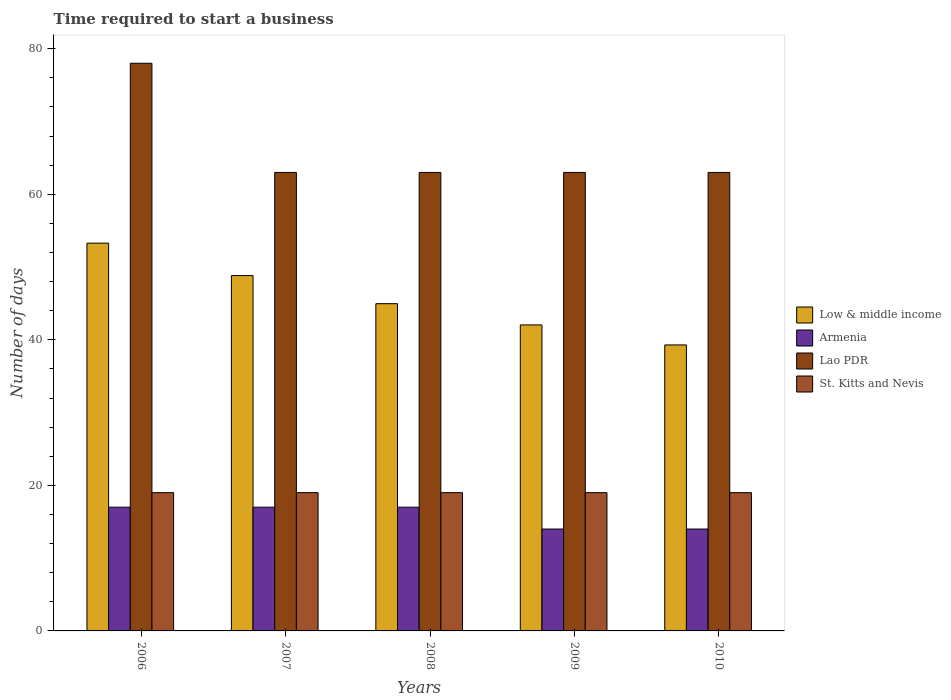How many groups of bars are there?
Keep it short and to the point. 5. Are the number of bars per tick equal to the number of legend labels?
Offer a very short reply. Yes. Are the number of bars on each tick of the X-axis equal?
Your answer should be very brief. Yes. What is the label of the 1st group of bars from the left?
Keep it short and to the point. 2006. In how many cases, is the number of bars for a given year not equal to the number of legend labels?
Offer a very short reply. 0. What is the number of days required to start a business in Low & middle income in 2008?
Provide a short and direct response. 44.97. Across all years, what is the maximum number of days required to start a business in Armenia?
Offer a very short reply. 17. Across all years, what is the minimum number of days required to start a business in Armenia?
Offer a terse response. 14. In which year was the number of days required to start a business in St. Kitts and Nevis maximum?
Your response must be concise. 2006. What is the total number of days required to start a business in Lao PDR in the graph?
Offer a very short reply. 330. What is the difference between the number of days required to start a business in Low & middle income in 2007 and that in 2009?
Provide a succinct answer. 6.78. What is the difference between the number of days required to start a business in Lao PDR in 2007 and the number of days required to start a business in Armenia in 2008?
Your answer should be very brief. 46. In the year 2007, what is the difference between the number of days required to start a business in St. Kitts and Nevis and number of days required to start a business in Armenia?
Your response must be concise. 2. In how many years, is the number of days required to start a business in Lao PDR greater than 12 days?
Provide a short and direct response. 5. Is the number of days required to start a business in Lao PDR in 2006 less than that in 2008?
Offer a terse response. No. What is the difference between the highest and the lowest number of days required to start a business in Low & middle income?
Ensure brevity in your answer.  13.99. In how many years, is the number of days required to start a business in Lao PDR greater than the average number of days required to start a business in Lao PDR taken over all years?
Your response must be concise. 1. What does the 2nd bar from the right in 2007 represents?
Offer a terse response. Lao PDR. Is it the case that in every year, the sum of the number of days required to start a business in St. Kitts and Nevis and number of days required to start a business in Low & middle income is greater than the number of days required to start a business in Lao PDR?
Provide a short and direct response. No. Are the values on the major ticks of Y-axis written in scientific E-notation?
Provide a short and direct response. No. Does the graph contain any zero values?
Your answer should be very brief. No. How many legend labels are there?
Offer a terse response. 4. How are the legend labels stacked?
Offer a terse response. Vertical. What is the title of the graph?
Provide a succinct answer. Time required to start a business. Does "Curacao" appear as one of the legend labels in the graph?
Your response must be concise. No. What is the label or title of the Y-axis?
Give a very brief answer. Number of days. What is the Number of days of Low & middle income in 2006?
Provide a short and direct response. 53.28. What is the Number of days in Armenia in 2006?
Make the answer very short. 17. What is the Number of days of Low & middle income in 2007?
Your answer should be compact. 48.82. What is the Number of days of Armenia in 2007?
Make the answer very short. 17. What is the Number of days of Lao PDR in 2007?
Make the answer very short. 63. What is the Number of days of Low & middle income in 2008?
Keep it short and to the point. 44.97. What is the Number of days of Armenia in 2008?
Provide a short and direct response. 17. What is the Number of days in St. Kitts and Nevis in 2008?
Your response must be concise. 19. What is the Number of days of Low & middle income in 2009?
Make the answer very short. 42.05. What is the Number of days in Armenia in 2009?
Your answer should be very brief. 14. What is the Number of days of St. Kitts and Nevis in 2009?
Provide a short and direct response. 19. What is the Number of days in Low & middle income in 2010?
Make the answer very short. 39.3. What is the Number of days of Lao PDR in 2010?
Your answer should be very brief. 63. What is the Number of days in St. Kitts and Nevis in 2010?
Provide a succinct answer. 19. Across all years, what is the maximum Number of days in Low & middle income?
Your answer should be very brief. 53.28. Across all years, what is the minimum Number of days in Low & middle income?
Keep it short and to the point. 39.3. Across all years, what is the minimum Number of days in Lao PDR?
Keep it short and to the point. 63. What is the total Number of days of Low & middle income in the graph?
Your answer should be compact. 228.42. What is the total Number of days of Armenia in the graph?
Your answer should be compact. 79. What is the total Number of days in Lao PDR in the graph?
Your answer should be compact. 330. What is the difference between the Number of days in Low & middle income in 2006 and that in 2007?
Provide a short and direct response. 4.46. What is the difference between the Number of days of Low & middle income in 2006 and that in 2008?
Provide a succinct answer. 8.32. What is the difference between the Number of days of Lao PDR in 2006 and that in 2008?
Make the answer very short. 15. What is the difference between the Number of days of Low & middle income in 2006 and that in 2009?
Offer a very short reply. 11.24. What is the difference between the Number of days of Armenia in 2006 and that in 2009?
Your response must be concise. 3. What is the difference between the Number of days of Lao PDR in 2006 and that in 2009?
Your answer should be very brief. 15. What is the difference between the Number of days of St. Kitts and Nevis in 2006 and that in 2009?
Offer a terse response. 0. What is the difference between the Number of days in Low & middle income in 2006 and that in 2010?
Provide a succinct answer. 13.99. What is the difference between the Number of days in Armenia in 2006 and that in 2010?
Offer a terse response. 3. What is the difference between the Number of days in Lao PDR in 2006 and that in 2010?
Your answer should be compact. 15. What is the difference between the Number of days in Low & middle income in 2007 and that in 2008?
Your response must be concise. 3.86. What is the difference between the Number of days in Low & middle income in 2007 and that in 2009?
Make the answer very short. 6.78. What is the difference between the Number of days in Armenia in 2007 and that in 2009?
Ensure brevity in your answer.  3. What is the difference between the Number of days of Lao PDR in 2007 and that in 2009?
Provide a succinct answer. 0. What is the difference between the Number of days in St. Kitts and Nevis in 2007 and that in 2009?
Make the answer very short. 0. What is the difference between the Number of days in Low & middle income in 2007 and that in 2010?
Ensure brevity in your answer.  9.53. What is the difference between the Number of days of Armenia in 2007 and that in 2010?
Provide a succinct answer. 3. What is the difference between the Number of days in Low & middle income in 2008 and that in 2009?
Offer a very short reply. 2.92. What is the difference between the Number of days of Low & middle income in 2008 and that in 2010?
Provide a short and direct response. 5.67. What is the difference between the Number of days of Lao PDR in 2008 and that in 2010?
Your answer should be very brief. 0. What is the difference between the Number of days of St. Kitts and Nevis in 2008 and that in 2010?
Provide a short and direct response. 0. What is the difference between the Number of days of Low & middle income in 2009 and that in 2010?
Your answer should be very brief. 2.75. What is the difference between the Number of days in St. Kitts and Nevis in 2009 and that in 2010?
Give a very brief answer. 0. What is the difference between the Number of days in Low & middle income in 2006 and the Number of days in Armenia in 2007?
Provide a short and direct response. 36.28. What is the difference between the Number of days in Low & middle income in 2006 and the Number of days in Lao PDR in 2007?
Keep it short and to the point. -9.72. What is the difference between the Number of days of Low & middle income in 2006 and the Number of days of St. Kitts and Nevis in 2007?
Give a very brief answer. 34.28. What is the difference between the Number of days in Armenia in 2006 and the Number of days in Lao PDR in 2007?
Make the answer very short. -46. What is the difference between the Number of days in Lao PDR in 2006 and the Number of days in St. Kitts and Nevis in 2007?
Offer a very short reply. 59. What is the difference between the Number of days of Low & middle income in 2006 and the Number of days of Armenia in 2008?
Give a very brief answer. 36.28. What is the difference between the Number of days in Low & middle income in 2006 and the Number of days in Lao PDR in 2008?
Provide a succinct answer. -9.72. What is the difference between the Number of days in Low & middle income in 2006 and the Number of days in St. Kitts and Nevis in 2008?
Your answer should be compact. 34.28. What is the difference between the Number of days of Armenia in 2006 and the Number of days of Lao PDR in 2008?
Give a very brief answer. -46. What is the difference between the Number of days in Armenia in 2006 and the Number of days in St. Kitts and Nevis in 2008?
Provide a succinct answer. -2. What is the difference between the Number of days of Lao PDR in 2006 and the Number of days of St. Kitts and Nevis in 2008?
Your answer should be very brief. 59. What is the difference between the Number of days in Low & middle income in 2006 and the Number of days in Armenia in 2009?
Provide a short and direct response. 39.28. What is the difference between the Number of days of Low & middle income in 2006 and the Number of days of Lao PDR in 2009?
Ensure brevity in your answer.  -9.72. What is the difference between the Number of days of Low & middle income in 2006 and the Number of days of St. Kitts and Nevis in 2009?
Give a very brief answer. 34.28. What is the difference between the Number of days in Armenia in 2006 and the Number of days in Lao PDR in 2009?
Your answer should be compact. -46. What is the difference between the Number of days of Low & middle income in 2006 and the Number of days of Armenia in 2010?
Provide a succinct answer. 39.28. What is the difference between the Number of days of Low & middle income in 2006 and the Number of days of Lao PDR in 2010?
Offer a terse response. -9.72. What is the difference between the Number of days of Low & middle income in 2006 and the Number of days of St. Kitts and Nevis in 2010?
Give a very brief answer. 34.28. What is the difference between the Number of days of Armenia in 2006 and the Number of days of Lao PDR in 2010?
Offer a terse response. -46. What is the difference between the Number of days of Armenia in 2006 and the Number of days of St. Kitts and Nevis in 2010?
Provide a short and direct response. -2. What is the difference between the Number of days in Lao PDR in 2006 and the Number of days in St. Kitts and Nevis in 2010?
Provide a succinct answer. 59. What is the difference between the Number of days of Low & middle income in 2007 and the Number of days of Armenia in 2008?
Give a very brief answer. 31.82. What is the difference between the Number of days in Low & middle income in 2007 and the Number of days in Lao PDR in 2008?
Ensure brevity in your answer.  -14.18. What is the difference between the Number of days in Low & middle income in 2007 and the Number of days in St. Kitts and Nevis in 2008?
Your response must be concise. 29.82. What is the difference between the Number of days of Armenia in 2007 and the Number of days of Lao PDR in 2008?
Provide a short and direct response. -46. What is the difference between the Number of days of Armenia in 2007 and the Number of days of St. Kitts and Nevis in 2008?
Keep it short and to the point. -2. What is the difference between the Number of days of Low & middle income in 2007 and the Number of days of Armenia in 2009?
Give a very brief answer. 34.82. What is the difference between the Number of days in Low & middle income in 2007 and the Number of days in Lao PDR in 2009?
Offer a terse response. -14.18. What is the difference between the Number of days in Low & middle income in 2007 and the Number of days in St. Kitts and Nevis in 2009?
Give a very brief answer. 29.82. What is the difference between the Number of days of Armenia in 2007 and the Number of days of Lao PDR in 2009?
Your answer should be compact. -46. What is the difference between the Number of days of Armenia in 2007 and the Number of days of St. Kitts and Nevis in 2009?
Offer a very short reply. -2. What is the difference between the Number of days of Low & middle income in 2007 and the Number of days of Armenia in 2010?
Make the answer very short. 34.82. What is the difference between the Number of days of Low & middle income in 2007 and the Number of days of Lao PDR in 2010?
Offer a terse response. -14.18. What is the difference between the Number of days in Low & middle income in 2007 and the Number of days in St. Kitts and Nevis in 2010?
Keep it short and to the point. 29.82. What is the difference between the Number of days of Armenia in 2007 and the Number of days of Lao PDR in 2010?
Give a very brief answer. -46. What is the difference between the Number of days of Low & middle income in 2008 and the Number of days of Armenia in 2009?
Ensure brevity in your answer.  30.97. What is the difference between the Number of days in Low & middle income in 2008 and the Number of days in Lao PDR in 2009?
Keep it short and to the point. -18.03. What is the difference between the Number of days in Low & middle income in 2008 and the Number of days in St. Kitts and Nevis in 2009?
Provide a short and direct response. 25.97. What is the difference between the Number of days of Armenia in 2008 and the Number of days of Lao PDR in 2009?
Your response must be concise. -46. What is the difference between the Number of days in Armenia in 2008 and the Number of days in St. Kitts and Nevis in 2009?
Keep it short and to the point. -2. What is the difference between the Number of days of Low & middle income in 2008 and the Number of days of Armenia in 2010?
Your response must be concise. 30.97. What is the difference between the Number of days in Low & middle income in 2008 and the Number of days in Lao PDR in 2010?
Your answer should be very brief. -18.03. What is the difference between the Number of days of Low & middle income in 2008 and the Number of days of St. Kitts and Nevis in 2010?
Your answer should be very brief. 25.97. What is the difference between the Number of days in Armenia in 2008 and the Number of days in Lao PDR in 2010?
Your answer should be very brief. -46. What is the difference between the Number of days of Lao PDR in 2008 and the Number of days of St. Kitts and Nevis in 2010?
Your response must be concise. 44. What is the difference between the Number of days in Low & middle income in 2009 and the Number of days in Armenia in 2010?
Provide a short and direct response. 28.05. What is the difference between the Number of days of Low & middle income in 2009 and the Number of days of Lao PDR in 2010?
Ensure brevity in your answer.  -20.95. What is the difference between the Number of days of Low & middle income in 2009 and the Number of days of St. Kitts and Nevis in 2010?
Offer a terse response. 23.05. What is the difference between the Number of days in Armenia in 2009 and the Number of days in Lao PDR in 2010?
Offer a very short reply. -49. What is the difference between the Number of days in Armenia in 2009 and the Number of days in St. Kitts and Nevis in 2010?
Your response must be concise. -5. What is the average Number of days of Low & middle income per year?
Your answer should be compact. 45.68. What is the average Number of days in Lao PDR per year?
Offer a terse response. 66. What is the average Number of days of St. Kitts and Nevis per year?
Give a very brief answer. 19. In the year 2006, what is the difference between the Number of days in Low & middle income and Number of days in Armenia?
Provide a succinct answer. 36.28. In the year 2006, what is the difference between the Number of days of Low & middle income and Number of days of Lao PDR?
Provide a succinct answer. -24.72. In the year 2006, what is the difference between the Number of days in Low & middle income and Number of days in St. Kitts and Nevis?
Provide a short and direct response. 34.28. In the year 2006, what is the difference between the Number of days of Armenia and Number of days of Lao PDR?
Provide a succinct answer. -61. In the year 2007, what is the difference between the Number of days in Low & middle income and Number of days in Armenia?
Ensure brevity in your answer.  31.82. In the year 2007, what is the difference between the Number of days of Low & middle income and Number of days of Lao PDR?
Offer a terse response. -14.18. In the year 2007, what is the difference between the Number of days of Low & middle income and Number of days of St. Kitts and Nevis?
Offer a very short reply. 29.82. In the year 2007, what is the difference between the Number of days of Armenia and Number of days of Lao PDR?
Provide a short and direct response. -46. In the year 2007, what is the difference between the Number of days in Lao PDR and Number of days in St. Kitts and Nevis?
Provide a short and direct response. 44. In the year 2008, what is the difference between the Number of days in Low & middle income and Number of days in Armenia?
Provide a succinct answer. 27.97. In the year 2008, what is the difference between the Number of days of Low & middle income and Number of days of Lao PDR?
Provide a succinct answer. -18.03. In the year 2008, what is the difference between the Number of days in Low & middle income and Number of days in St. Kitts and Nevis?
Offer a terse response. 25.97. In the year 2008, what is the difference between the Number of days of Armenia and Number of days of Lao PDR?
Make the answer very short. -46. In the year 2008, what is the difference between the Number of days of Armenia and Number of days of St. Kitts and Nevis?
Provide a succinct answer. -2. In the year 2009, what is the difference between the Number of days of Low & middle income and Number of days of Armenia?
Provide a succinct answer. 28.05. In the year 2009, what is the difference between the Number of days in Low & middle income and Number of days in Lao PDR?
Make the answer very short. -20.95. In the year 2009, what is the difference between the Number of days of Low & middle income and Number of days of St. Kitts and Nevis?
Your answer should be compact. 23.05. In the year 2009, what is the difference between the Number of days in Armenia and Number of days in Lao PDR?
Your answer should be very brief. -49. In the year 2010, what is the difference between the Number of days of Low & middle income and Number of days of Armenia?
Give a very brief answer. 25.3. In the year 2010, what is the difference between the Number of days in Low & middle income and Number of days in Lao PDR?
Make the answer very short. -23.7. In the year 2010, what is the difference between the Number of days in Low & middle income and Number of days in St. Kitts and Nevis?
Ensure brevity in your answer.  20.3. In the year 2010, what is the difference between the Number of days of Armenia and Number of days of Lao PDR?
Offer a very short reply. -49. In the year 2010, what is the difference between the Number of days of Armenia and Number of days of St. Kitts and Nevis?
Make the answer very short. -5. In the year 2010, what is the difference between the Number of days of Lao PDR and Number of days of St. Kitts and Nevis?
Keep it short and to the point. 44. What is the ratio of the Number of days of Low & middle income in 2006 to that in 2007?
Keep it short and to the point. 1.09. What is the ratio of the Number of days in Armenia in 2006 to that in 2007?
Offer a very short reply. 1. What is the ratio of the Number of days in Lao PDR in 2006 to that in 2007?
Your response must be concise. 1.24. What is the ratio of the Number of days of Low & middle income in 2006 to that in 2008?
Ensure brevity in your answer.  1.18. What is the ratio of the Number of days in Lao PDR in 2006 to that in 2008?
Offer a very short reply. 1.24. What is the ratio of the Number of days of Low & middle income in 2006 to that in 2009?
Give a very brief answer. 1.27. What is the ratio of the Number of days in Armenia in 2006 to that in 2009?
Ensure brevity in your answer.  1.21. What is the ratio of the Number of days in Lao PDR in 2006 to that in 2009?
Give a very brief answer. 1.24. What is the ratio of the Number of days in Low & middle income in 2006 to that in 2010?
Provide a succinct answer. 1.36. What is the ratio of the Number of days of Armenia in 2006 to that in 2010?
Keep it short and to the point. 1.21. What is the ratio of the Number of days in Lao PDR in 2006 to that in 2010?
Offer a terse response. 1.24. What is the ratio of the Number of days in Low & middle income in 2007 to that in 2008?
Provide a succinct answer. 1.09. What is the ratio of the Number of days of Armenia in 2007 to that in 2008?
Offer a terse response. 1. What is the ratio of the Number of days in St. Kitts and Nevis in 2007 to that in 2008?
Your answer should be compact. 1. What is the ratio of the Number of days in Low & middle income in 2007 to that in 2009?
Ensure brevity in your answer.  1.16. What is the ratio of the Number of days of Armenia in 2007 to that in 2009?
Give a very brief answer. 1.21. What is the ratio of the Number of days in Lao PDR in 2007 to that in 2009?
Provide a succinct answer. 1. What is the ratio of the Number of days of Low & middle income in 2007 to that in 2010?
Your answer should be very brief. 1.24. What is the ratio of the Number of days of Armenia in 2007 to that in 2010?
Offer a very short reply. 1.21. What is the ratio of the Number of days of Lao PDR in 2007 to that in 2010?
Provide a short and direct response. 1. What is the ratio of the Number of days of St. Kitts and Nevis in 2007 to that in 2010?
Offer a terse response. 1. What is the ratio of the Number of days of Low & middle income in 2008 to that in 2009?
Your response must be concise. 1.07. What is the ratio of the Number of days in Armenia in 2008 to that in 2009?
Make the answer very short. 1.21. What is the ratio of the Number of days in Low & middle income in 2008 to that in 2010?
Your response must be concise. 1.14. What is the ratio of the Number of days in Armenia in 2008 to that in 2010?
Your answer should be very brief. 1.21. What is the ratio of the Number of days of Low & middle income in 2009 to that in 2010?
Make the answer very short. 1.07. What is the ratio of the Number of days in Lao PDR in 2009 to that in 2010?
Give a very brief answer. 1. What is the difference between the highest and the second highest Number of days in Low & middle income?
Your answer should be compact. 4.46. What is the difference between the highest and the second highest Number of days in Armenia?
Offer a very short reply. 0. What is the difference between the highest and the second highest Number of days in Lao PDR?
Provide a short and direct response. 15. What is the difference between the highest and the second highest Number of days in St. Kitts and Nevis?
Give a very brief answer. 0. What is the difference between the highest and the lowest Number of days of Low & middle income?
Offer a terse response. 13.99. What is the difference between the highest and the lowest Number of days in Lao PDR?
Your answer should be compact. 15. What is the difference between the highest and the lowest Number of days of St. Kitts and Nevis?
Your answer should be very brief. 0. 